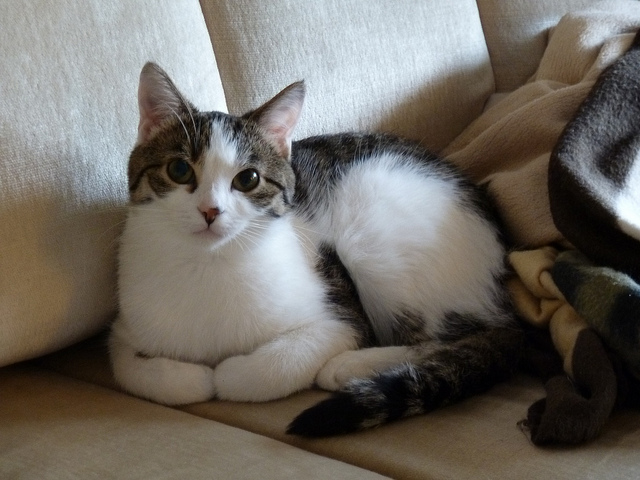<image>Is the pattern on the couch strips? No, the pattern on the couch is not strips. It's plain. Is the pattern on the couch strips? It is unanswerable if the pattern on the couch is strips or not. 